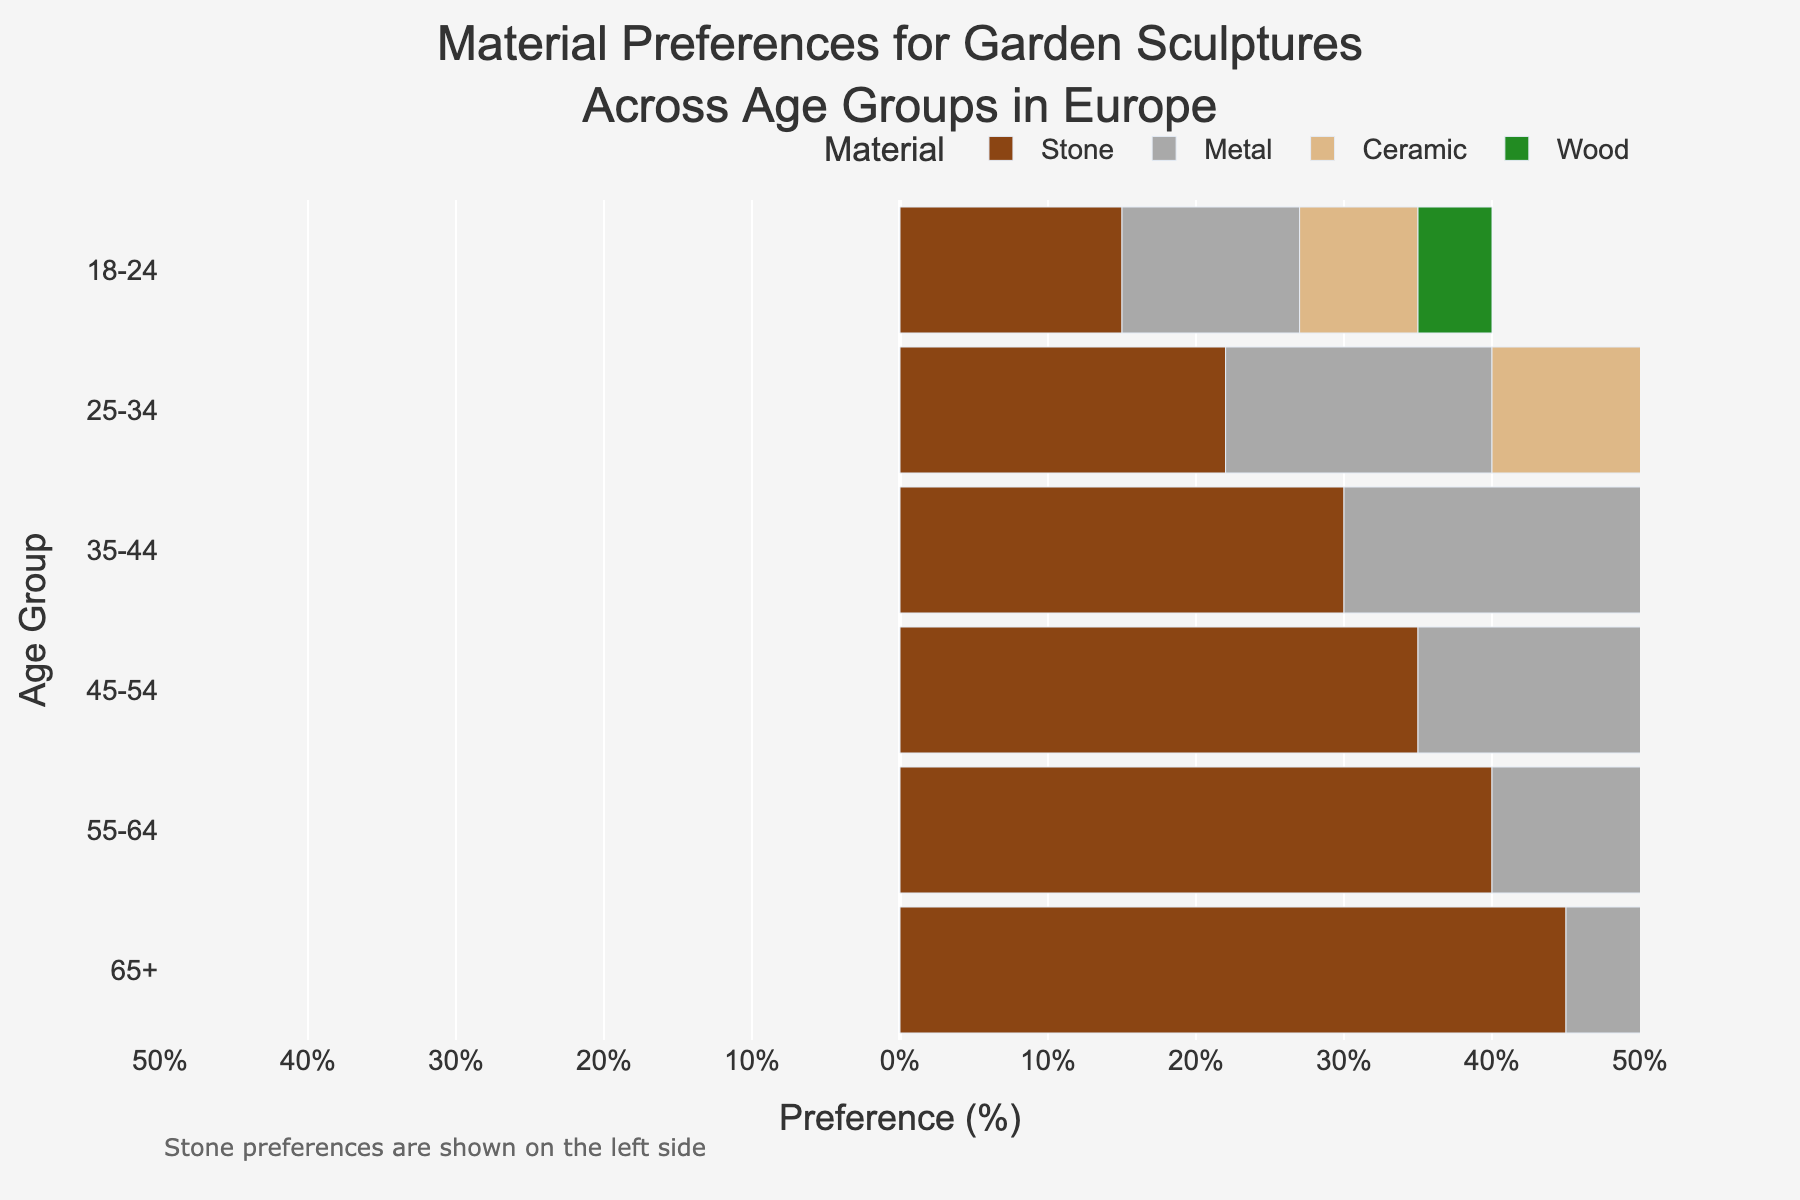How does the preference for stone sculptures change across age groups? The preference for stone sculptures increases as age increases, represented by increasingly negative bars from the youngest to the oldest age group.
Answer: Increases with age What is the percentage preference for ceramic sculptures in the 25-34 age group? Locate the 25-34 row and find the value under the "Ceramic" column.
Answer: 12% Which age group shows the highest preference for metal sculptures? By comparing the values for metal across different age groups, the 55-64 age group has the highest preference.
Answer: 55-64 What's the total preference percentage for wood in the age groups 35-44 and 45-54 combined? Add the values for wood in both age groups: 12 (35-44) + 15 (45-54).
Answer: 27% Compare the preference for stone and ceramic materials in the age group 65+. Which is higher? For the 65+ age group, compare -45 (stone) and 20 (ceramic). Ceramic has a higher positive value.
Answer: Ceramic Which material shows a declining preference as age increases? Examine all columns to find which has decreasing values. Metal's highest point is 32 at 55-64 then decreases.
Answer: Metal What is the median preference for metal sculptures across all age groups? List the preferences for metal, sort them and find the middle value for: 12, 18, 25, 28, 30, 32. The median is (25+28)/2 = 26.5.
Answer: 26.5% How do preferences for wood and ceramic compare in the 18-24 and 35-44 age groups? Check both age groups and compare the values for wood and ceramic. For 18-24: 5 (wood), 8 (ceramic); for 35-44: 12 (wood), 18 (ceramic). Ceramic has higher preference in both cases.
Answer: Ceramic higher What can you infer about the preference trends for garden sculptures material in older age groups? Generally, stone preference increases significantly with age, whereas metal and wood preferences reach a peak around 55-64 and then vary.
Answer: Stone increases, metal and wood peak at 55-64 What's the average preference percentage for stone sculptures across all age groups? Sum the stone preferences as positive values and find the average: (15 + 22 + 30 + 35 + 40 + 45) / 6 = 187 / 6 ≈ 31.2%
Answer: 31.2% 